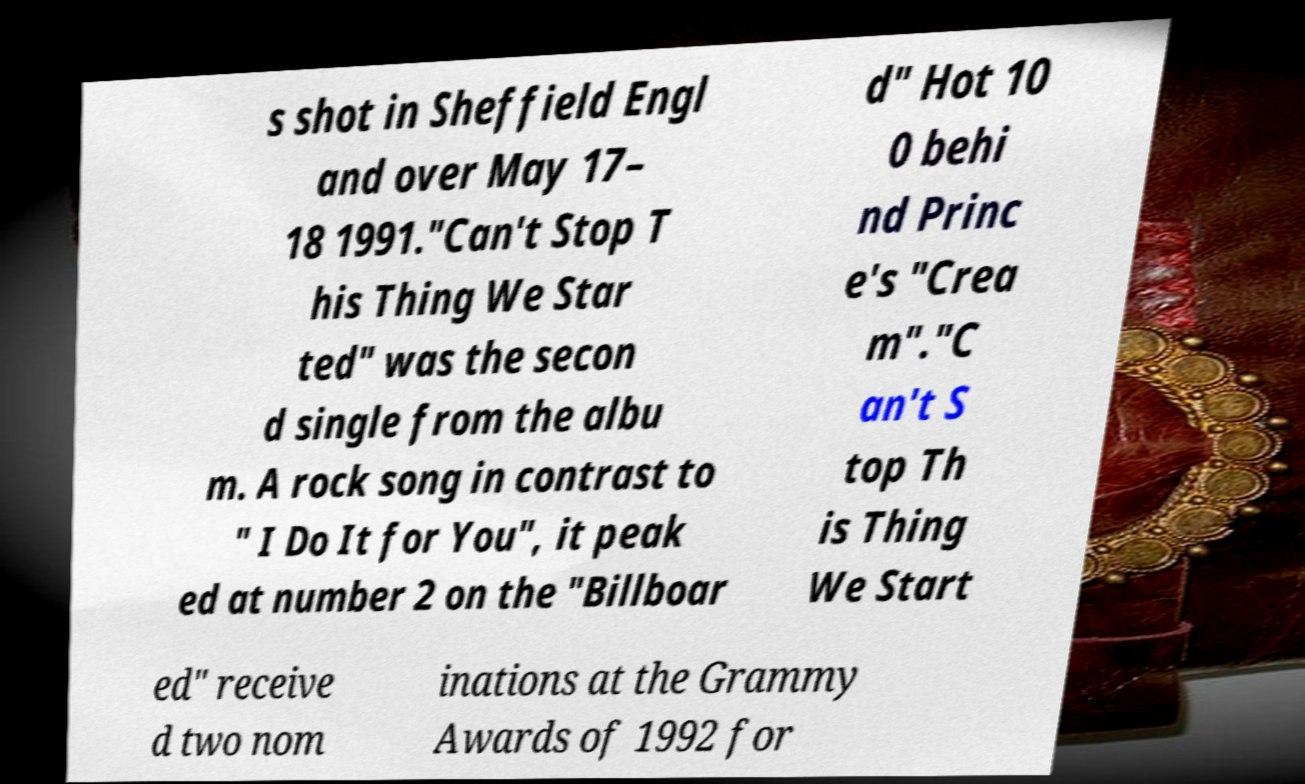I need the written content from this picture converted into text. Can you do that? s shot in Sheffield Engl and over May 17– 18 1991."Can't Stop T his Thing We Star ted" was the secon d single from the albu m. A rock song in contrast to " I Do It for You", it peak ed at number 2 on the "Billboar d" Hot 10 0 behi nd Princ e's "Crea m"."C an't S top Th is Thing We Start ed" receive d two nom inations at the Grammy Awards of 1992 for 